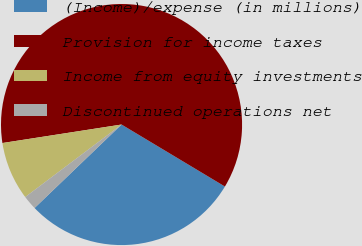Convert chart to OTSL. <chart><loc_0><loc_0><loc_500><loc_500><pie_chart><fcel>(Income)/expense (in millions)<fcel>Provision for income taxes<fcel>Income from equity investments<fcel>Discontinued operations net<nl><fcel>29.23%<fcel>61.05%<fcel>7.82%<fcel>1.9%<nl></chart> 